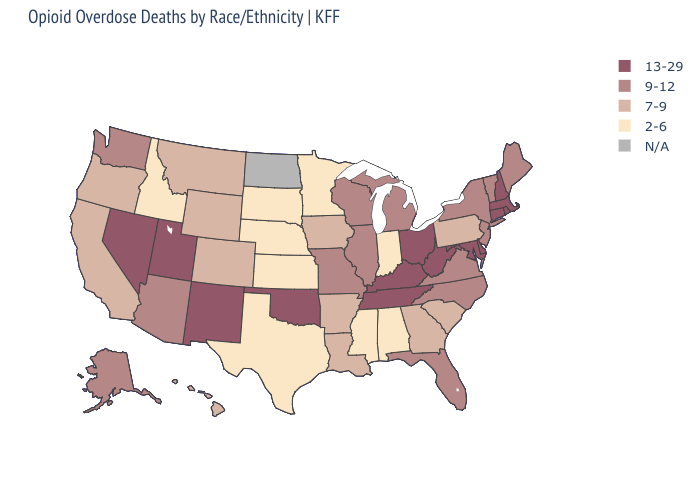Is the legend a continuous bar?
Write a very short answer. No. What is the value of New Mexico?
Concise answer only. 13-29. Which states have the lowest value in the MidWest?
Write a very short answer. Indiana, Kansas, Minnesota, Nebraska, South Dakota. Among the states that border Vermont , which have the highest value?
Keep it brief. Massachusetts, New Hampshire. What is the lowest value in states that border Oregon?
Concise answer only. 2-6. Does New Mexico have the highest value in the West?
Be succinct. Yes. Name the states that have a value in the range 9-12?
Quick response, please. Alaska, Arizona, Florida, Illinois, Maine, Michigan, Missouri, New Jersey, New York, North Carolina, Vermont, Virginia, Washington, Wisconsin. What is the value of Maine?
Write a very short answer. 9-12. Among the states that border Kansas , does Oklahoma have the highest value?
Quick response, please. Yes. What is the value of Mississippi?
Give a very brief answer. 2-6. Name the states that have a value in the range 7-9?
Keep it brief. Arkansas, California, Colorado, Georgia, Hawaii, Iowa, Louisiana, Montana, Oregon, Pennsylvania, South Carolina, Wyoming. Which states have the lowest value in the USA?
Answer briefly. Alabama, Idaho, Indiana, Kansas, Minnesota, Mississippi, Nebraska, South Dakota, Texas. Does the first symbol in the legend represent the smallest category?
Quick response, please. No. What is the value of Minnesota?
Be succinct. 2-6. What is the value of Massachusetts?
Write a very short answer. 13-29. 